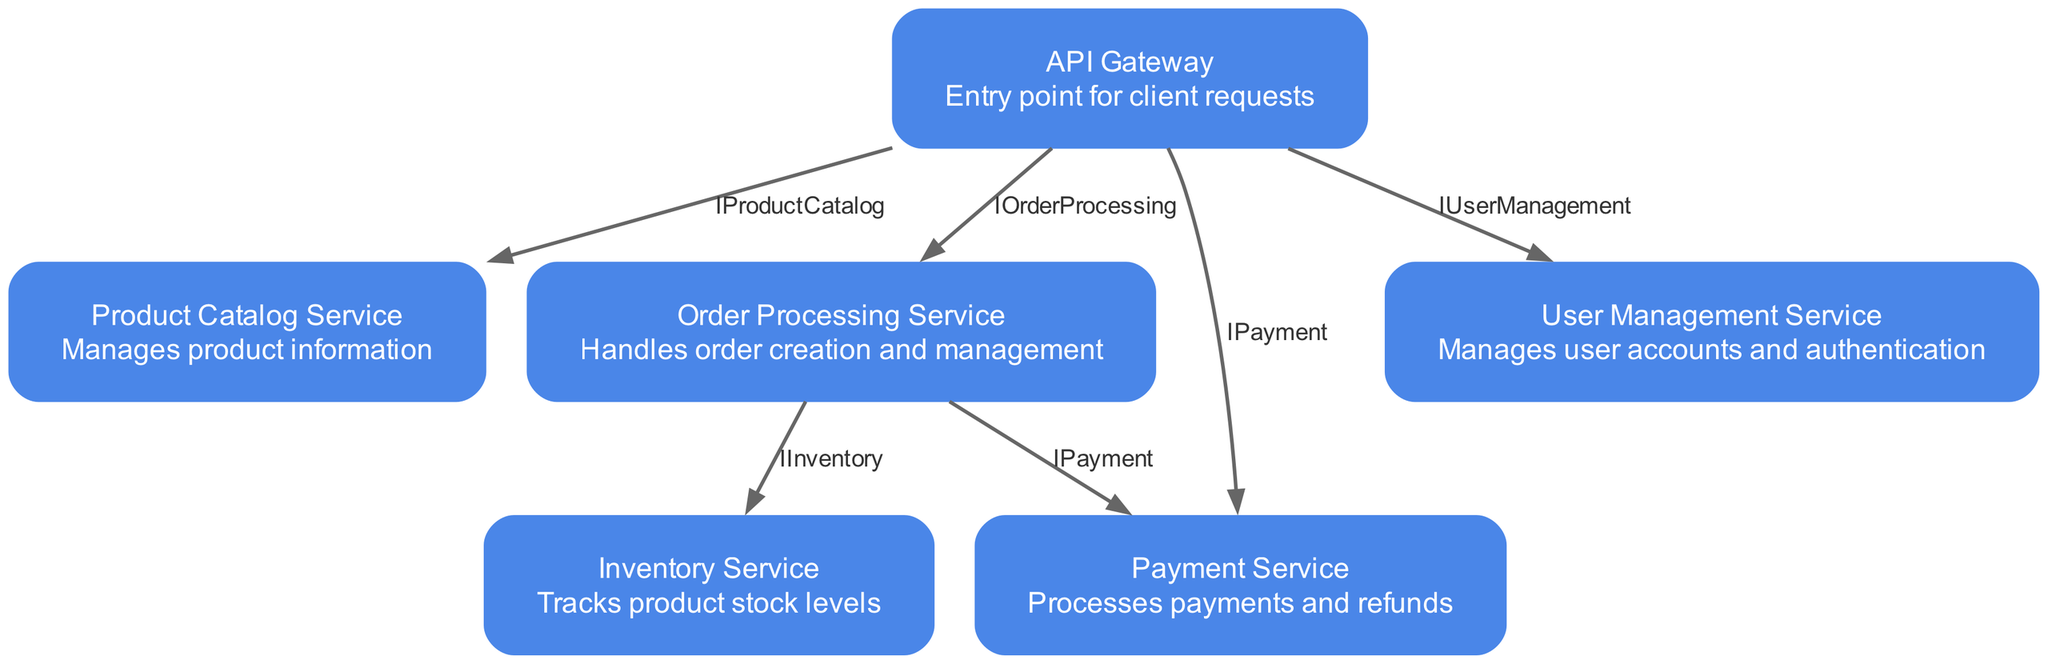What is the entry point for client requests? The diagram identifies the "API Gateway" as the entry point for all client requests. This can be seen as a distinct node labeled "API Gateway" among the other service nodes.
Answer: API Gateway How many services are there in total? By counting the nodes listed in the diagram, we see there are six distinct services: API Gateway, Product Catalog Service, Order Processing Service, Payment Service, User Management Service, and Inventory Service.
Answer: 6 Which service manages user accounts? The "User Management Service" is explicitly mentioned in the diagram as the service responsible for managing user accounts and authentication, which is described directly in the node information.
Answer: User Management Service What kind of interaction occurs between API Gateway and Product Catalog Service? The interaction is labeled as "IProductCatalog," indicating that the API Gateway uses this interface to connect to the Product Catalog Service as shown by the edge connecting those two nodes.
Answer: IProductCatalog If an order is processed, which other service does it interact with for payment? The "Order Processing Service" interacts with the "Payment Service" for payment processing. This is noted by the edge labeled "IPayment" connecting these two services.
Answer: Payment Service What is the purpose of the Inventory Service? The "Inventory Service" is designed to track product stock levels according to its description, which can be found in the visual representation of the service node in the diagram.
Answer: Tracks product stock levels Which service does the Order Processing Service interact with apart from the Payment Service? The Order Processing Service interacts with the Inventory Service, as indicated by the edge labeled "IInventory" connecting them. This requires examining the edges departing from the Order Processing Service node.
Answer: Inventory Service How many edges are there in total? By counting the defined connections (edges) between services in the diagram, we find there are five edges that illustrate the interactions, as listed in the data.
Answer: 5 What interface does the Order Processing Service use to manage orders? The service uses the interface labeled "IOrderProcessing" to manage orders, which connects it from the API Gateway in the diagram.
Answer: IOrderProcessing 